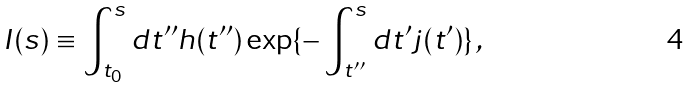Convert formula to latex. <formula><loc_0><loc_0><loc_500><loc_500>I ( s ) \equiv \int _ { t _ { 0 } } ^ { s } { d } t ^ { \prime \prime } h ( t ^ { \prime \prime } ) \exp \{ - \int _ { t ^ { \prime \prime } } ^ { s } { d } t ^ { \prime } j ( t ^ { \prime } ) \} \, ,</formula> 